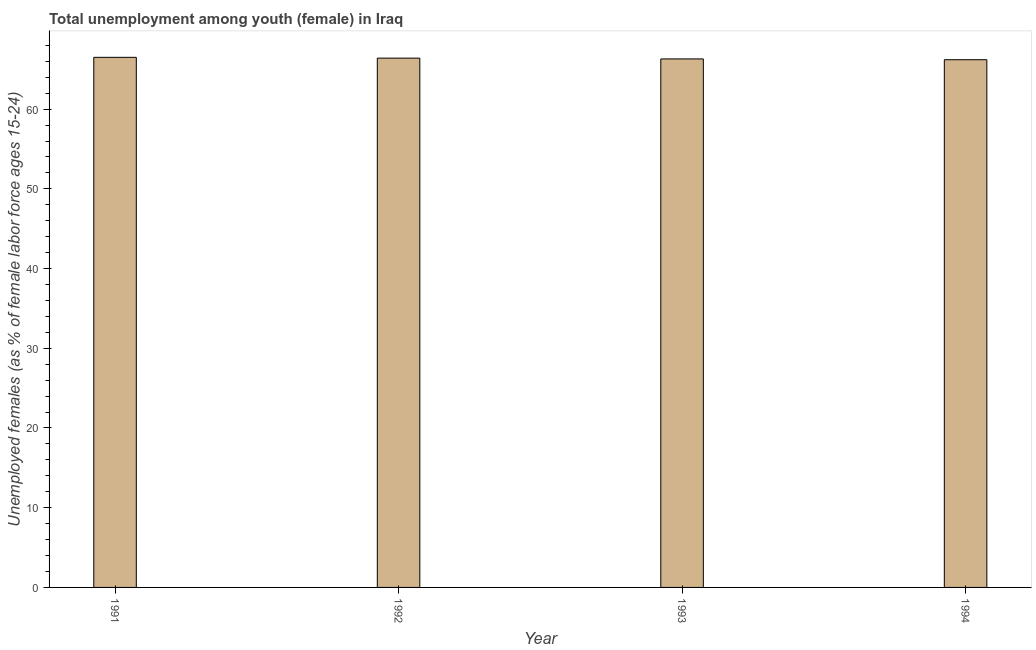Does the graph contain any zero values?
Provide a succinct answer. No. What is the title of the graph?
Your response must be concise. Total unemployment among youth (female) in Iraq. What is the label or title of the Y-axis?
Keep it short and to the point. Unemployed females (as % of female labor force ages 15-24). What is the unemployed female youth population in 1993?
Your answer should be very brief. 66.3. Across all years, what is the maximum unemployed female youth population?
Make the answer very short. 66.5. Across all years, what is the minimum unemployed female youth population?
Offer a terse response. 66.2. What is the sum of the unemployed female youth population?
Make the answer very short. 265.4. What is the average unemployed female youth population per year?
Keep it short and to the point. 66.35. What is the median unemployed female youth population?
Make the answer very short. 66.35. In how many years, is the unemployed female youth population greater than 14 %?
Keep it short and to the point. 4. Is the difference between the unemployed female youth population in 1991 and 1994 greater than the difference between any two years?
Your response must be concise. Yes. What is the difference between the highest and the second highest unemployed female youth population?
Provide a short and direct response. 0.1. What is the difference between the highest and the lowest unemployed female youth population?
Give a very brief answer. 0.3. How many bars are there?
Give a very brief answer. 4. Are all the bars in the graph horizontal?
Provide a succinct answer. No. Are the values on the major ticks of Y-axis written in scientific E-notation?
Offer a terse response. No. What is the Unemployed females (as % of female labor force ages 15-24) of 1991?
Provide a succinct answer. 66.5. What is the Unemployed females (as % of female labor force ages 15-24) of 1992?
Provide a short and direct response. 66.4. What is the Unemployed females (as % of female labor force ages 15-24) of 1993?
Your answer should be compact. 66.3. What is the Unemployed females (as % of female labor force ages 15-24) of 1994?
Provide a succinct answer. 66.2. What is the difference between the Unemployed females (as % of female labor force ages 15-24) in 1991 and 1993?
Provide a succinct answer. 0.2. What is the difference between the Unemployed females (as % of female labor force ages 15-24) in 1993 and 1994?
Give a very brief answer. 0.1. What is the ratio of the Unemployed females (as % of female labor force ages 15-24) in 1991 to that in 1992?
Keep it short and to the point. 1. What is the ratio of the Unemployed females (as % of female labor force ages 15-24) in 1991 to that in 1993?
Offer a terse response. 1. What is the ratio of the Unemployed females (as % of female labor force ages 15-24) in 1991 to that in 1994?
Your answer should be very brief. 1. What is the ratio of the Unemployed females (as % of female labor force ages 15-24) in 1992 to that in 1993?
Give a very brief answer. 1. What is the ratio of the Unemployed females (as % of female labor force ages 15-24) in 1992 to that in 1994?
Offer a very short reply. 1. What is the ratio of the Unemployed females (as % of female labor force ages 15-24) in 1993 to that in 1994?
Your response must be concise. 1. 